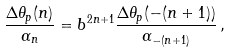Convert formula to latex. <formula><loc_0><loc_0><loc_500><loc_500>\frac { \Delta \theta _ { p } ( n ) } { \alpha _ { n } } = b ^ { 2 n + 1 } \frac { \Delta \theta _ { p } ( - ( n + 1 ) ) } { \alpha _ { - ( n + 1 ) } } \, ,</formula> 